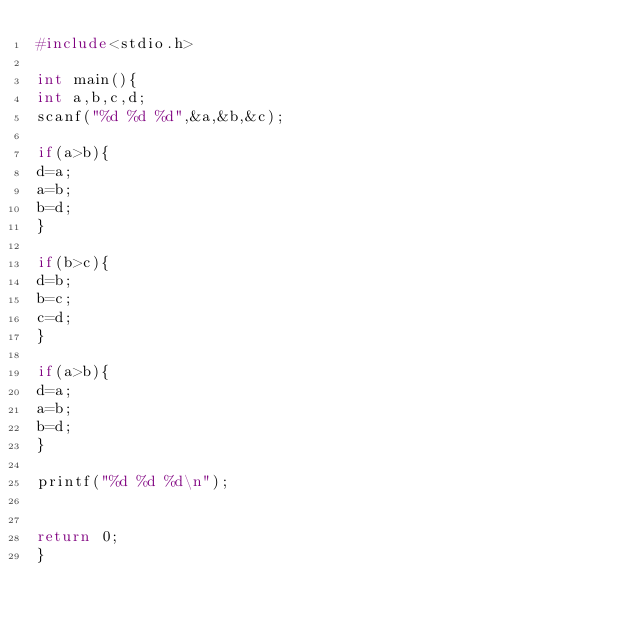<code> <loc_0><loc_0><loc_500><loc_500><_C_>#include<stdio.h>

int main(){
int a,b,c,d;
scanf("%d %d %d",&a,&b,&c);

if(a>b){
d=a;
a=b;
b=d;
}

if(b>c){
d=b;
b=c;
c=d;
}

if(a>b){
d=a;
a=b;
b=d;
}

printf("%d %d %d\n");


return 0;
}</code> 